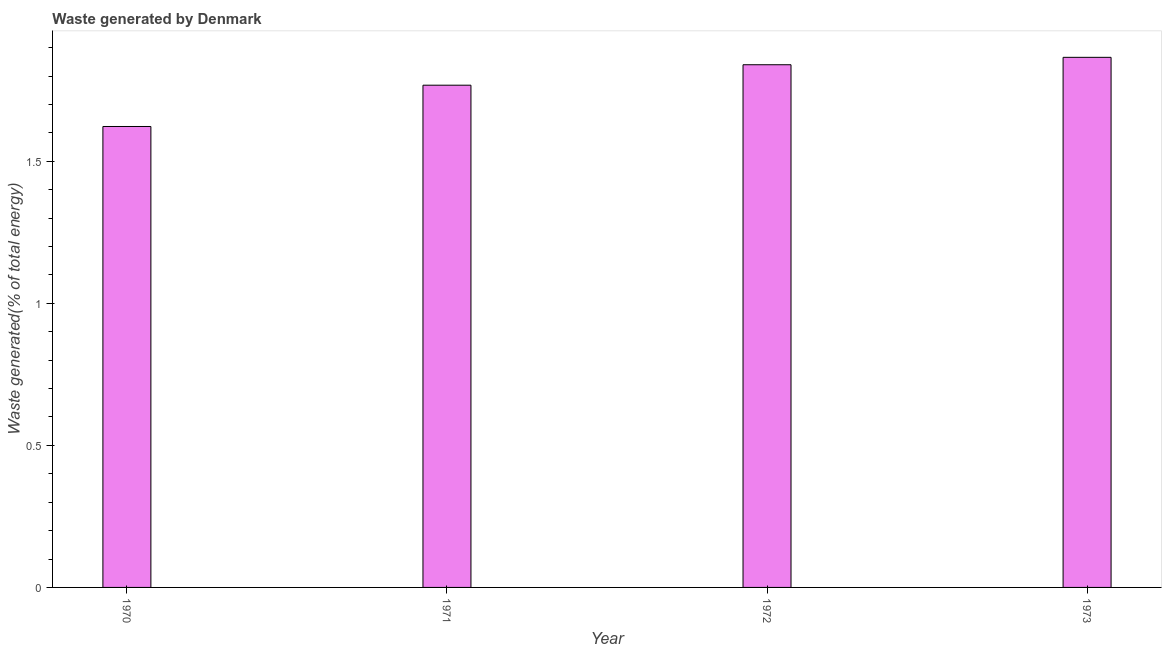Does the graph contain grids?
Your answer should be compact. No. What is the title of the graph?
Ensure brevity in your answer.  Waste generated by Denmark. What is the label or title of the Y-axis?
Offer a very short reply. Waste generated(% of total energy). What is the amount of waste generated in 1971?
Offer a very short reply. 1.77. Across all years, what is the maximum amount of waste generated?
Ensure brevity in your answer.  1.87. Across all years, what is the minimum amount of waste generated?
Ensure brevity in your answer.  1.62. What is the sum of the amount of waste generated?
Provide a succinct answer. 7.1. What is the difference between the amount of waste generated in 1971 and 1973?
Provide a short and direct response. -0.1. What is the average amount of waste generated per year?
Your answer should be very brief. 1.77. What is the median amount of waste generated?
Offer a terse response. 1.8. In how many years, is the amount of waste generated greater than 1 %?
Provide a succinct answer. 4. What is the ratio of the amount of waste generated in 1970 to that in 1971?
Your answer should be compact. 0.92. What is the difference between the highest and the second highest amount of waste generated?
Give a very brief answer. 0.03. Is the sum of the amount of waste generated in 1972 and 1973 greater than the maximum amount of waste generated across all years?
Offer a terse response. Yes. What is the difference between the highest and the lowest amount of waste generated?
Ensure brevity in your answer.  0.24. How many bars are there?
Your answer should be compact. 4. Are all the bars in the graph horizontal?
Keep it short and to the point. No. What is the difference between two consecutive major ticks on the Y-axis?
Provide a short and direct response. 0.5. What is the Waste generated(% of total energy) in 1970?
Your answer should be very brief. 1.62. What is the Waste generated(% of total energy) of 1971?
Your answer should be very brief. 1.77. What is the Waste generated(% of total energy) in 1972?
Make the answer very short. 1.84. What is the Waste generated(% of total energy) of 1973?
Make the answer very short. 1.87. What is the difference between the Waste generated(% of total energy) in 1970 and 1971?
Ensure brevity in your answer.  -0.15. What is the difference between the Waste generated(% of total energy) in 1970 and 1972?
Provide a short and direct response. -0.22. What is the difference between the Waste generated(% of total energy) in 1970 and 1973?
Ensure brevity in your answer.  -0.24. What is the difference between the Waste generated(% of total energy) in 1971 and 1972?
Offer a terse response. -0.07. What is the difference between the Waste generated(% of total energy) in 1971 and 1973?
Your answer should be compact. -0.1. What is the difference between the Waste generated(% of total energy) in 1972 and 1973?
Give a very brief answer. -0.03. What is the ratio of the Waste generated(% of total energy) in 1970 to that in 1971?
Provide a succinct answer. 0.92. What is the ratio of the Waste generated(% of total energy) in 1970 to that in 1972?
Ensure brevity in your answer.  0.88. What is the ratio of the Waste generated(% of total energy) in 1970 to that in 1973?
Provide a succinct answer. 0.87. What is the ratio of the Waste generated(% of total energy) in 1971 to that in 1972?
Give a very brief answer. 0.96. What is the ratio of the Waste generated(% of total energy) in 1971 to that in 1973?
Give a very brief answer. 0.95. What is the ratio of the Waste generated(% of total energy) in 1972 to that in 1973?
Offer a very short reply. 0.99. 